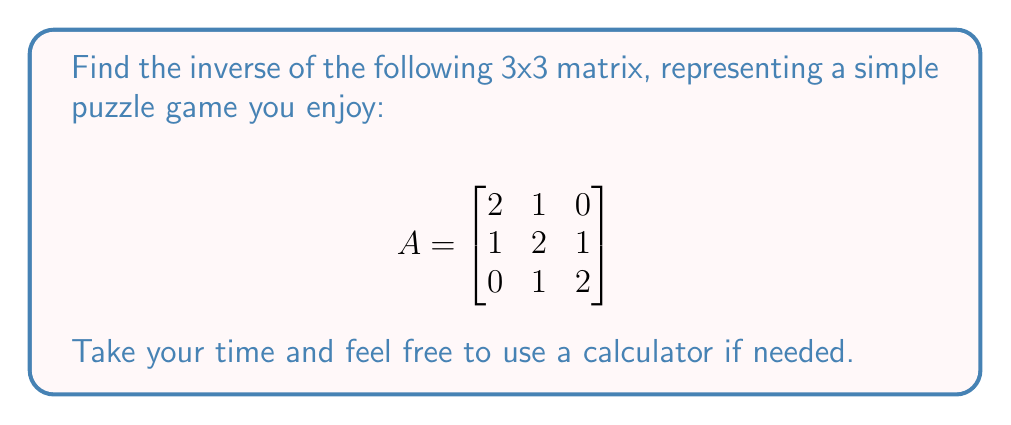Give your solution to this math problem. Let's find the inverse of matrix A step by step:

1. Calculate the determinant of A:
   $det(A) = 2(4-1) - 1(2-0) + 0(1-2) = 6 - 2 + 0 = 4$

2. Find the matrix of cofactors:
   $$C = \begin{bmatrix}
   4-1 & -(2-0) & 1-2 \\
   -(2-0) & 4-0 & -(2-0) \\
   1-2 & -(1-0) & 4-1
   \end{bmatrix} = \begin{bmatrix}
   3 & -2 & -1 \\
   -2 & 4 & -2 \\
   -1 & -1 & 3
   \end{bmatrix}$$

3. Transpose the matrix of cofactors:
   $$C^T = \begin{bmatrix}
   3 & -2 & -1 \\
   -2 & 4 & -1 \\
   -1 & -2 & 3
   \end{bmatrix}$$

4. Divide the transposed matrix of cofactors by the determinant:
   $$A^{-1} = \frac{1}{4} \begin{bmatrix}
   3 & -2 & -1 \\
   -2 & 4 & -1 \\
   -1 & -2 & 3
   \end{bmatrix}$$

5. Simplify the fractions:
   $$A^{-1} = \begin{bmatrix}
   3/4 & -1/2 & -1/4 \\
   -1/2 & 1 & -1/4 \\
   -1/4 & -1/2 & 3/4
   \end{bmatrix}$$
Answer: $$A^{-1} = \begin{bmatrix}
3/4 & -1/2 & -1/4 \\
-1/2 & 1 & -1/4 \\
-1/4 & -1/2 & 3/4
\end{bmatrix}$$ 